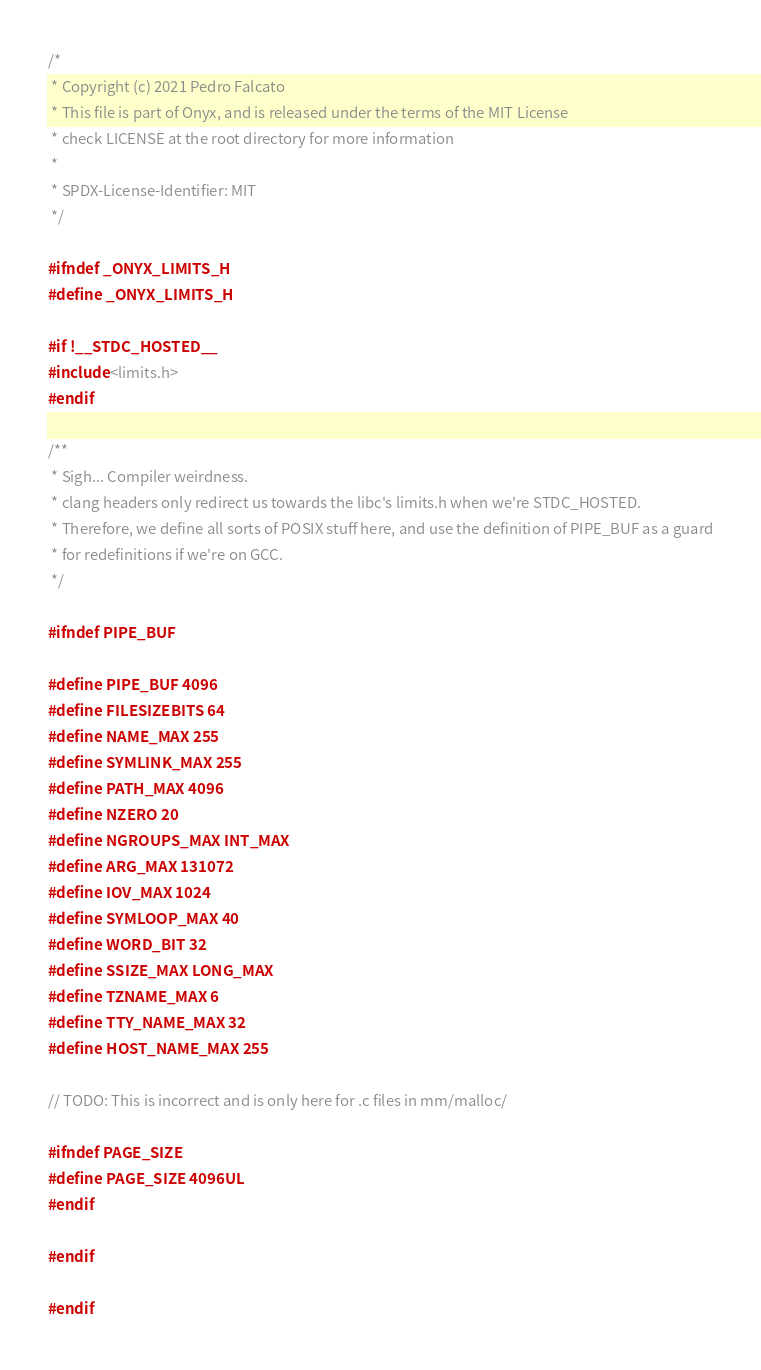Convert code to text. <code><loc_0><loc_0><loc_500><loc_500><_C_>/*
 * Copyright (c) 2021 Pedro Falcato
 * This file is part of Onyx, and is released under the terms of the MIT License
 * check LICENSE at the root directory for more information
 *
 * SPDX-License-Identifier: MIT
 */

#ifndef _ONYX_LIMITS_H
#define _ONYX_LIMITS_H

#if !__STDC_HOSTED__
#include <limits.h>
#endif

/**
 * Sigh... Compiler weirdness.
 * clang headers only redirect us towards the libc's limits.h when we're STDC_HOSTED.
 * Therefore, we define all sorts of POSIX stuff here, and use the definition of PIPE_BUF as a guard
 * for redefinitions if we're on GCC.
 */

#ifndef PIPE_BUF

#define PIPE_BUF 4096
#define FILESIZEBITS 64
#define NAME_MAX 255
#define SYMLINK_MAX 255
#define PATH_MAX 4096
#define NZERO 20
#define NGROUPS_MAX INT_MAX
#define ARG_MAX 131072
#define IOV_MAX 1024
#define SYMLOOP_MAX 40
#define WORD_BIT 32
#define SSIZE_MAX LONG_MAX
#define TZNAME_MAX 6
#define TTY_NAME_MAX 32
#define HOST_NAME_MAX 255

// TODO: This is incorrect and is only here for .c files in mm/malloc/

#ifndef PAGE_SIZE
#define PAGE_SIZE 4096UL
#endif

#endif

#endif
</code> 